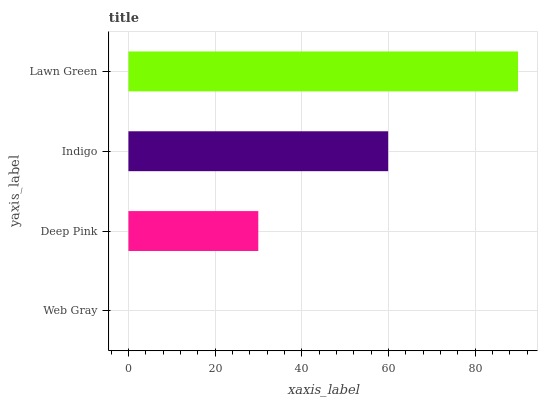Is Web Gray the minimum?
Answer yes or no. Yes. Is Lawn Green the maximum?
Answer yes or no. Yes. Is Deep Pink the minimum?
Answer yes or no. No. Is Deep Pink the maximum?
Answer yes or no. No. Is Deep Pink greater than Web Gray?
Answer yes or no. Yes. Is Web Gray less than Deep Pink?
Answer yes or no. Yes. Is Web Gray greater than Deep Pink?
Answer yes or no. No. Is Deep Pink less than Web Gray?
Answer yes or no. No. Is Indigo the high median?
Answer yes or no. Yes. Is Deep Pink the low median?
Answer yes or no. Yes. Is Deep Pink the high median?
Answer yes or no. No. Is Indigo the low median?
Answer yes or no. No. 